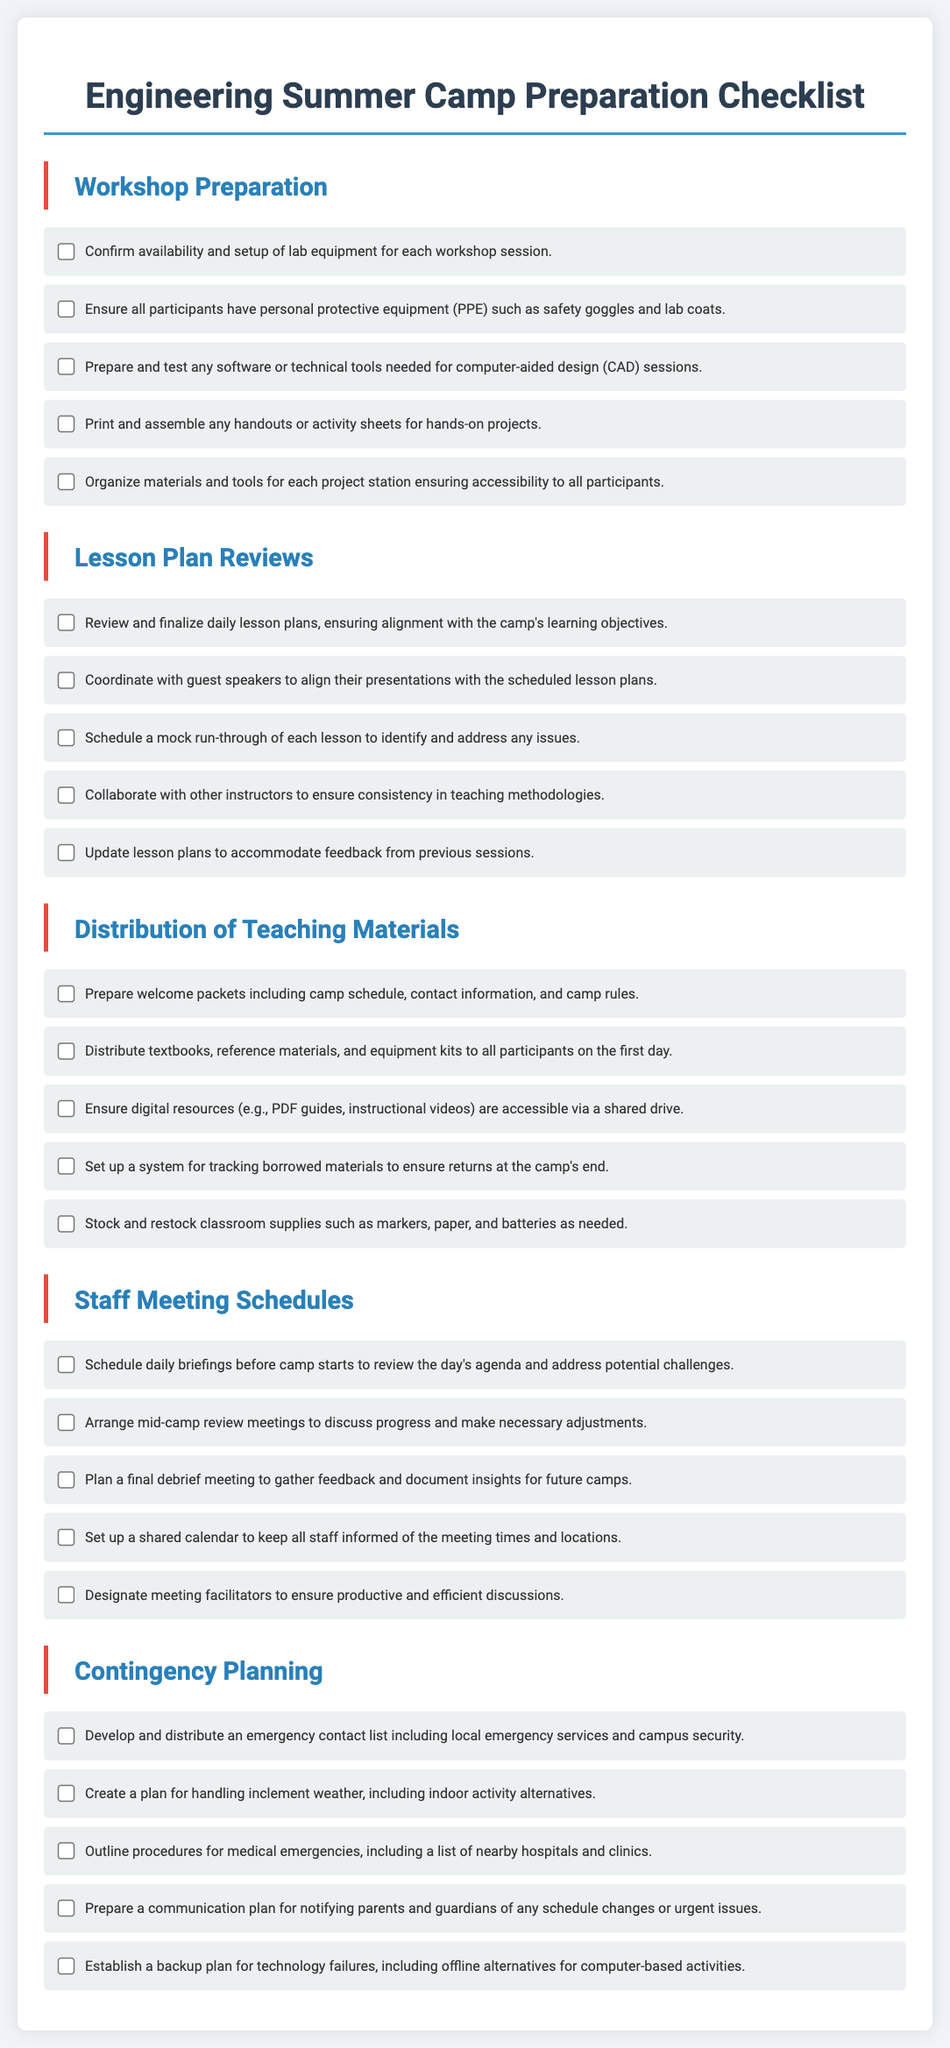What is the title of the document? The title is prominently displayed at the top and indicates the contents of the document.
Answer: Engineering Summer Camp Preparation Checklist How many sections are in the checklist? The document has five different sections as indicated by the headings.
Answer: 5 What item is listed under Workshop Preparation? The question focuses on one specific task listed in the Workshop Preparation section.
Answer: Confirm availability and setup of lab equipment for each workshop session What is one task related to Lesson Plan Reviews? This question seeks an example of the responsibilities outlined in the Lesson Plan Reviews section.
Answer: Review and finalize daily lesson plans, ensuring alignment with the camp's learning objectives What is included in the welcome packets? The welcome packets are mentioned as part of the Distribution of Teaching Materials section and specify their content.
Answer: Camp schedule, contact information, and camp rules How often are staff meetings scheduled? This question relates to the frequency of meetings as outlined in the Staff Meeting Schedules section.
Answer: Daily briefings What should be developed for contingency planning? The question targets a specific requirement outlined in the Contingency Planning section of the document.
Answer: Emergency contact list What is a procedure outlined for medical emergencies? The question asks for a specified procedure regarding medical emergencies from the Contingency Planning section.
Answer: List of nearby hospitals and clinics What should be established for technology failures? This question focuses on one of the contingency plans mentioned in the document.
Answer: Backup plan for technology failures 